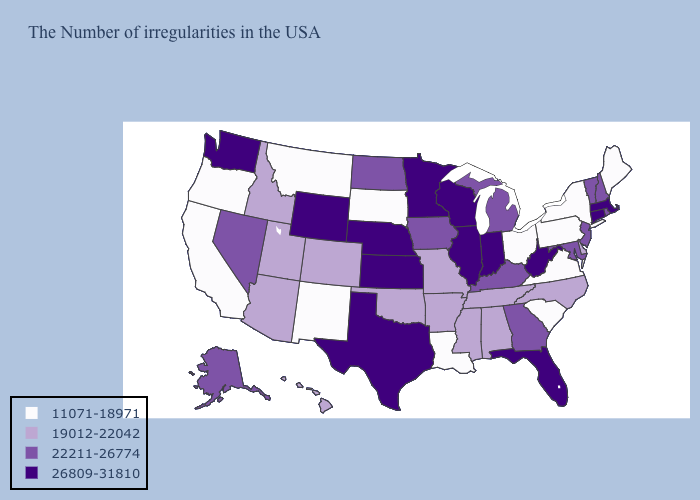Name the states that have a value in the range 26809-31810?
Quick response, please. Massachusetts, Connecticut, West Virginia, Florida, Indiana, Wisconsin, Illinois, Minnesota, Kansas, Nebraska, Texas, Wyoming, Washington. What is the highest value in states that border Virginia?
Answer briefly. 26809-31810. Does the map have missing data?
Short answer required. No. Which states have the lowest value in the South?
Quick response, please. Virginia, South Carolina, Louisiana. Among the states that border South Carolina , which have the highest value?
Quick response, please. Georgia. Name the states that have a value in the range 19012-22042?
Give a very brief answer. Delaware, North Carolina, Alabama, Tennessee, Mississippi, Missouri, Arkansas, Oklahoma, Colorado, Utah, Arizona, Idaho, Hawaii. Which states hav the highest value in the South?
Short answer required. West Virginia, Florida, Texas. Name the states that have a value in the range 22211-26774?
Write a very short answer. Rhode Island, New Hampshire, Vermont, New Jersey, Maryland, Georgia, Michigan, Kentucky, Iowa, North Dakota, Nevada, Alaska. Does the map have missing data?
Short answer required. No. Which states have the lowest value in the West?
Answer briefly. New Mexico, Montana, California, Oregon. Among the states that border Washington , does Idaho have the lowest value?
Concise answer only. No. Name the states that have a value in the range 26809-31810?
Write a very short answer. Massachusetts, Connecticut, West Virginia, Florida, Indiana, Wisconsin, Illinois, Minnesota, Kansas, Nebraska, Texas, Wyoming, Washington. Does the first symbol in the legend represent the smallest category?
Keep it brief. Yes. Does the first symbol in the legend represent the smallest category?
Write a very short answer. Yes. Name the states that have a value in the range 22211-26774?
Concise answer only. Rhode Island, New Hampshire, Vermont, New Jersey, Maryland, Georgia, Michigan, Kentucky, Iowa, North Dakota, Nevada, Alaska. 